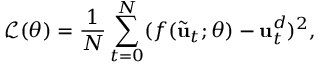<formula> <loc_0><loc_0><loc_500><loc_500>\mathcal { L } ( \theta ) = \frac { 1 } { N } \sum _ { t = 0 } ^ { N } ( f ( \tilde { u } _ { t } ; \theta ) - u _ { t } ^ { d } ) ^ { 2 } ,</formula> 